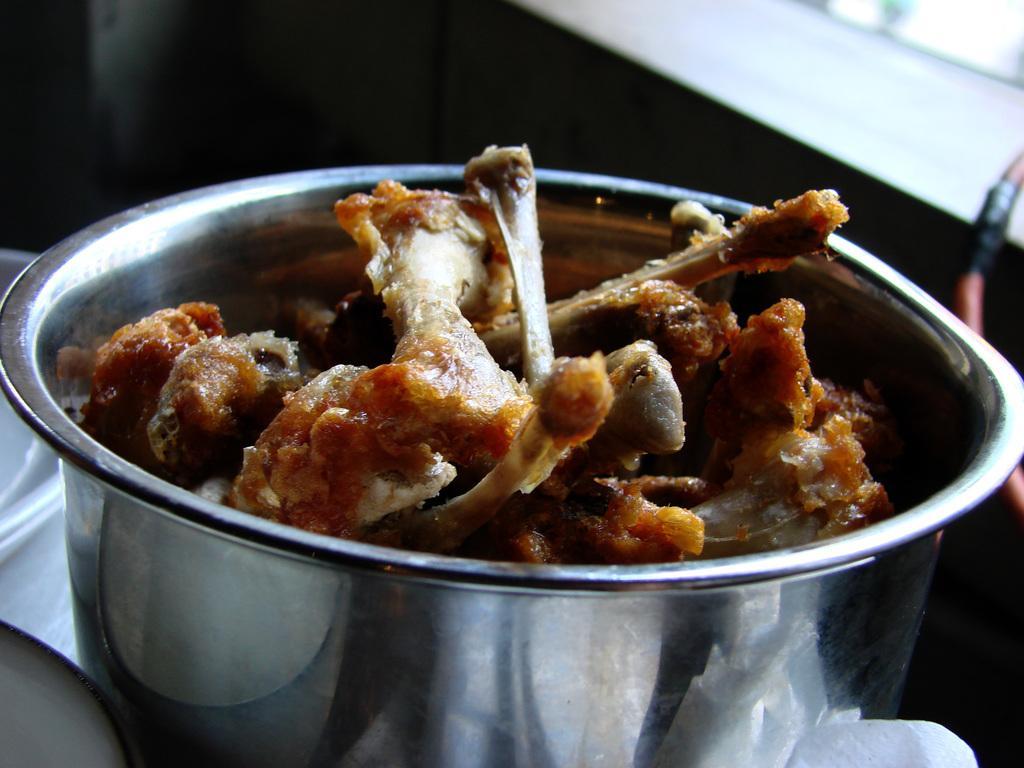Could you give a brief overview of what you see in this image? In this image we can see a bowl on the table which is filled with bones. 